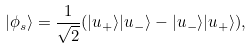<formula> <loc_0><loc_0><loc_500><loc_500>| \phi _ { s } \rangle = \frac { 1 } { \sqrt { 2 } } ( | u _ { + } \rangle | u _ { - } \rangle - | u _ { - } \rangle | u _ { + } \rangle ) ,</formula> 